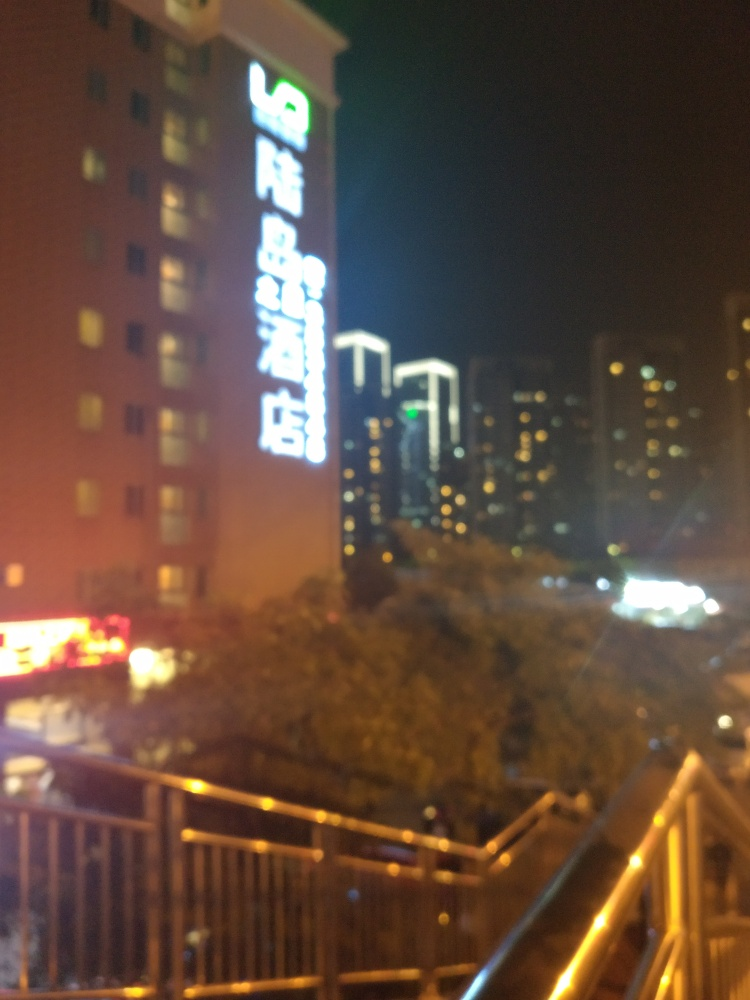Could you guess the location where this photo was taken based on the text in the image? The language of the text appears to be Chinese, which suggests the photo was likely taken in a Chinese-speaking region. However, without clearer text, it's challenging to determine a specific location. What can we infer about the area from the buildings in the background? The buildings in the background have a modern architectural style, implying an urban setting, possibly a downtown area of a city. 